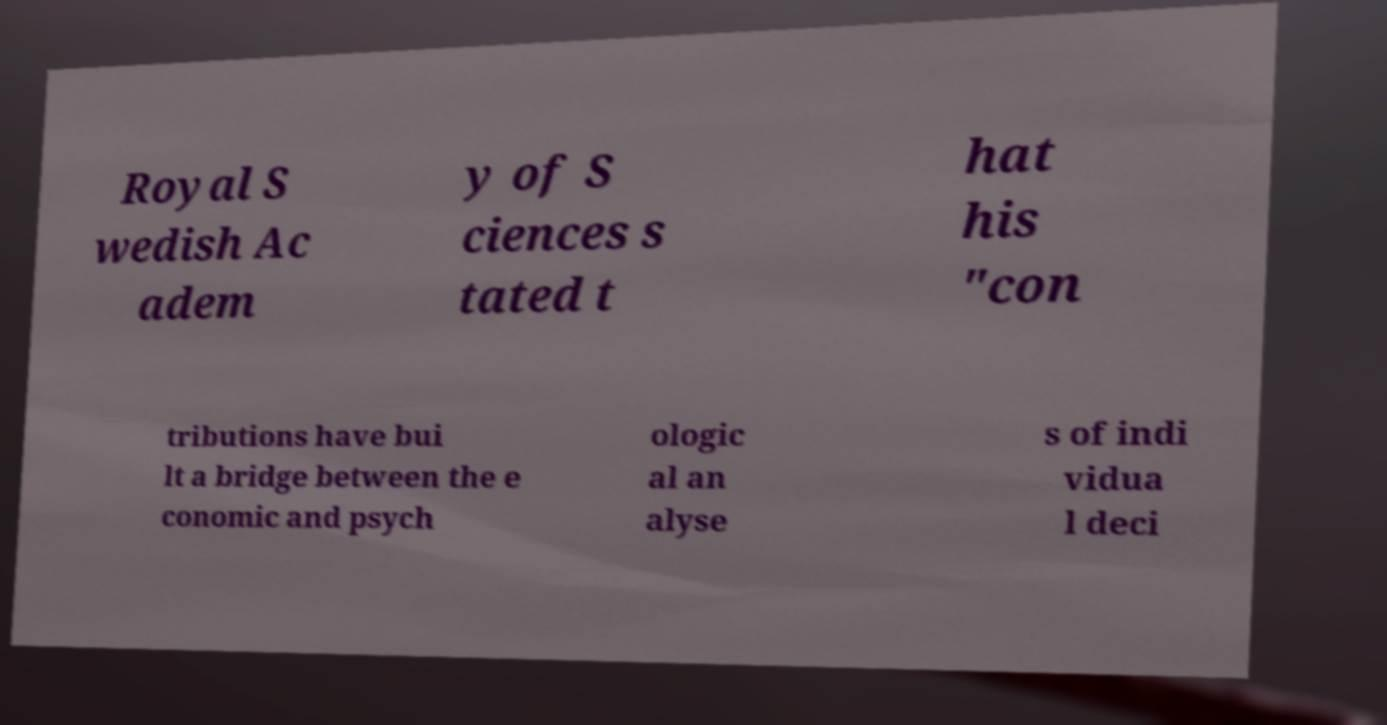What messages or text are displayed in this image? I need them in a readable, typed format. Royal S wedish Ac adem y of S ciences s tated t hat his "con tributions have bui lt a bridge between the e conomic and psych ologic al an alyse s of indi vidua l deci 